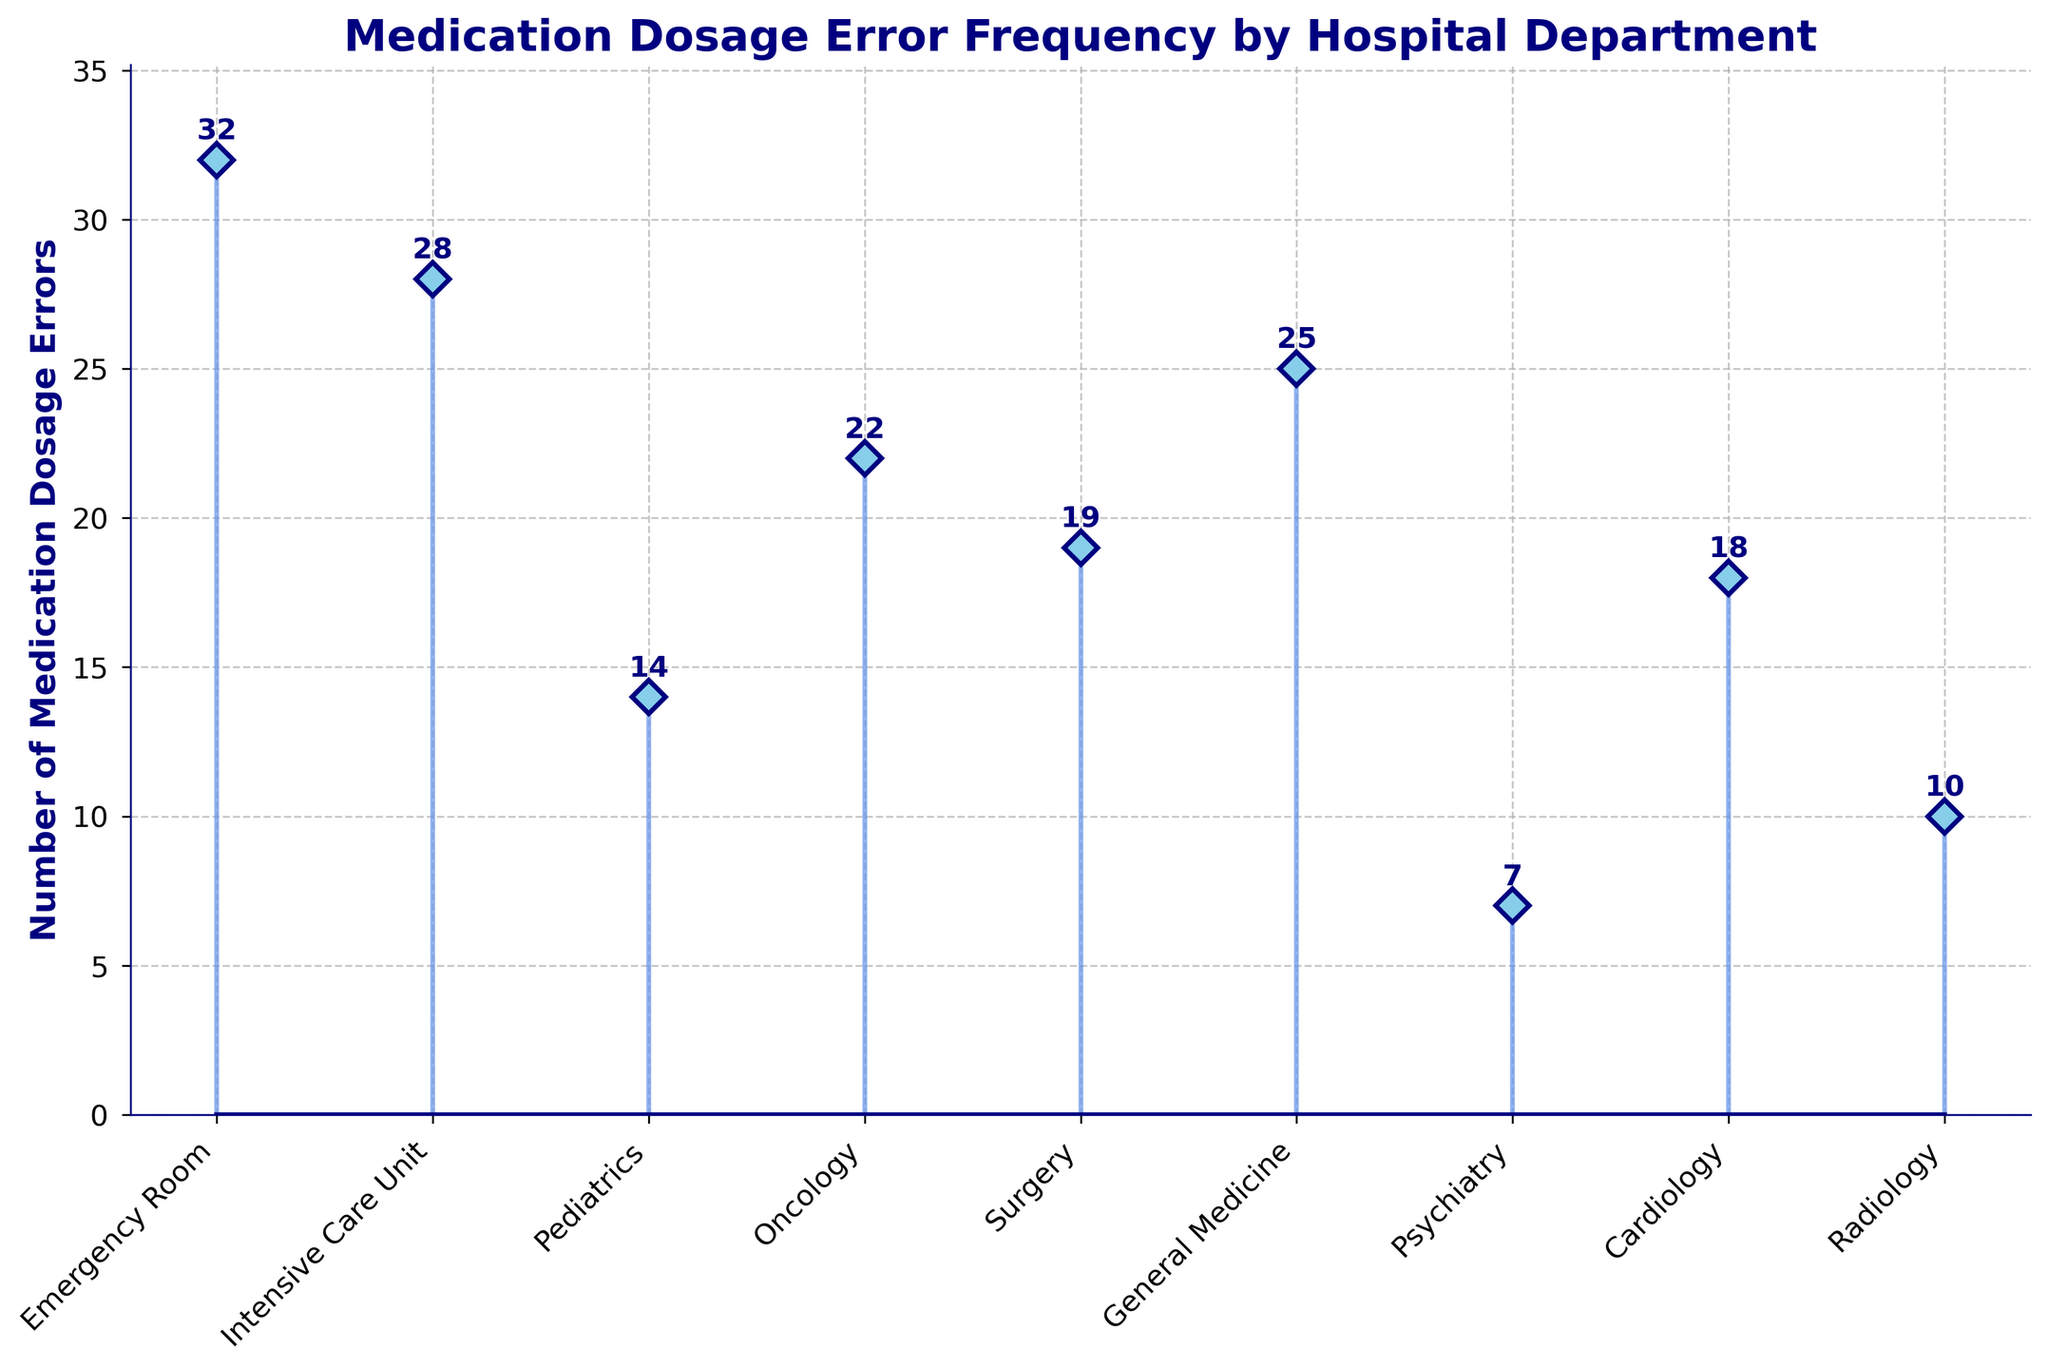What's the title of the figure? The title of the figure is found at the top and usually summarizes the data or insights represented in the plot.
Answer: Medication Dosage Error Frequency by Hospital Department Which department has the highest number of medication dosage errors? By inspecting the stems in the plot, the tallest stem represents the department with the most errors.
Answer: Emergency Room Which department has the lowest number of medication dosage errors? By looking at the stems, the shortest stem indicates the department with the fewest errors.
Answer: Psychiatry How many medication dosage errors are reported in the Oncology department? The height of the stem for the Oncology department corresponds to the number of errors.
Answer: 22 What is the total number of medication errors across all departments? To find the total, sum the number of errors for all departments: 32 + 28 + 14 + 22 + 19 + 25 + 7 + 18 + 10.
Answer: 175 What is the average number of medication dosage errors across all departments? The average is obtained by dividing the total number of errors by the number of departments: 175 / 9.
Answer: 19.44 Which departments have fewer than 15 medication dosage errors? Identify departments with stems shorter than the 15 mark on the y-axis.
Answer: Pediatrics, Psychiatry, Radiology What is the difference in medication dosage errors between the Emergency Room and Psychiatry? Subtract the number of errors in Psychiatry from those in the Emergency Room: 32 - 7.
Answer: 25 How many departments report more than 20 medication dosage errors? Count the stems that exceed the 20 mark on the y-axis.
Answer: 4 What is the median number of medication dosage errors across the departments? Arrange the error values in order and find the middle value: 7, 10, 14, 18, 19, 22, 25, 28, 32. The middle value (5th) is the median.
Answer: 19 